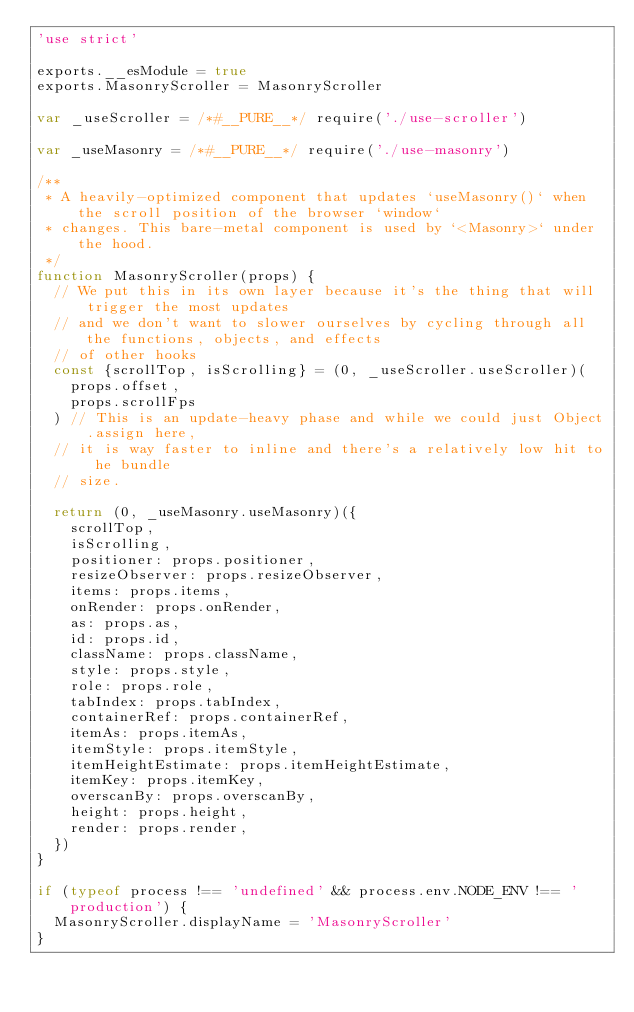Convert code to text. <code><loc_0><loc_0><loc_500><loc_500><_JavaScript_>'use strict'

exports.__esModule = true
exports.MasonryScroller = MasonryScroller

var _useScroller = /*#__PURE__*/ require('./use-scroller')

var _useMasonry = /*#__PURE__*/ require('./use-masonry')

/**
 * A heavily-optimized component that updates `useMasonry()` when the scroll position of the browser `window`
 * changes. This bare-metal component is used by `<Masonry>` under the hood.
 */
function MasonryScroller(props) {
  // We put this in its own layer because it's the thing that will trigger the most updates
  // and we don't want to slower ourselves by cycling through all the functions, objects, and effects
  // of other hooks
  const {scrollTop, isScrolling} = (0, _useScroller.useScroller)(
    props.offset,
    props.scrollFps
  ) // This is an update-heavy phase and while we could just Object.assign here,
  // it is way faster to inline and there's a relatively low hit to he bundle
  // size.

  return (0, _useMasonry.useMasonry)({
    scrollTop,
    isScrolling,
    positioner: props.positioner,
    resizeObserver: props.resizeObserver,
    items: props.items,
    onRender: props.onRender,
    as: props.as,
    id: props.id,
    className: props.className,
    style: props.style,
    role: props.role,
    tabIndex: props.tabIndex,
    containerRef: props.containerRef,
    itemAs: props.itemAs,
    itemStyle: props.itemStyle,
    itemHeightEstimate: props.itemHeightEstimate,
    itemKey: props.itemKey,
    overscanBy: props.overscanBy,
    height: props.height,
    render: props.render,
  })
}

if (typeof process !== 'undefined' && process.env.NODE_ENV !== 'production') {
  MasonryScroller.displayName = 'MasonryScroller'
}
</code> 